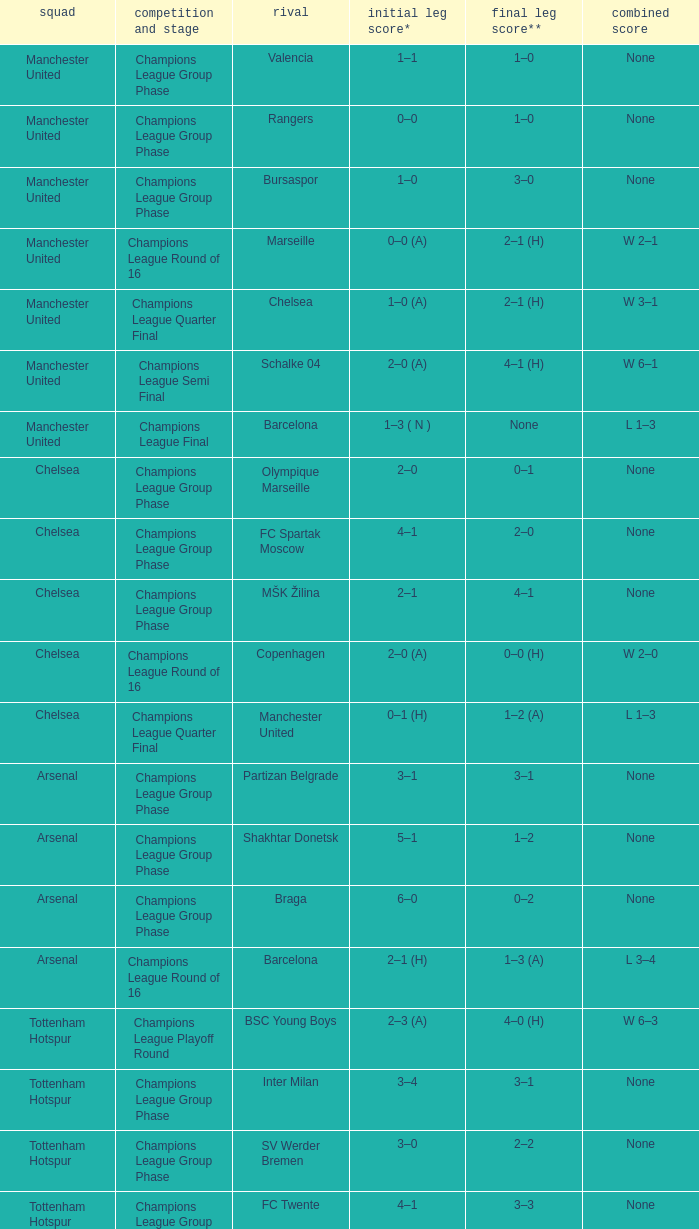How many goals did each team score in the first leg of the match between Liverpool and Steaua Bucureşti? 4–1. 